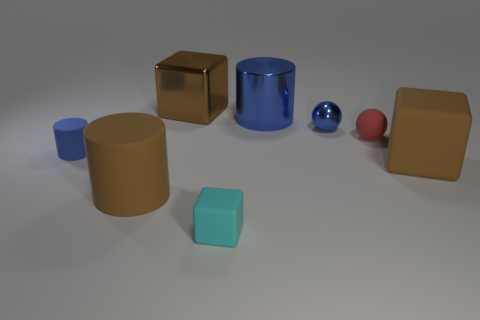There is a matte object that is the same color as the small metallic object; what size is it?
Ensure brevity in your answer.  Small. Are there any other cyan things that have the same shape as the cyan object?
Offer a terse response. No. The big metallic thing that is the same color as the tiny matte cylinder is what shape?
Give a very brief answer. Cylinder. There is a brown matte thing that is right of the big metal thing behind the big blue metal cylinder; are there any big brown cylinders that are behind it?
Ensure brevity in your answer.  No. There is a blue rubber object that is the same size as the blue metal ball; what is its shape?
Give a very brief answer. Cylinder. What color is the shiny thing that is the same shape as the cyan matte object?
Provide a succinct answer. Brown. What number of things are metallic balls or brown matte objects?
Ensure brevity in your answer.  3. Does the blue thing that is in front of the small red rubber sphere have the same shape as the thing in front of the brown rubber cylinder?
Give a very brief answer. No. What shape is the big brown object that is behind the blue rubber object?
Your answer should be very brief. Cube. Are there the same number of brown matte cylinders on the left side of the blue rubber cylinder and small red objects in front of the brown cylinder?
Keep it short and to the point. Yes. 